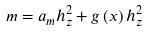Convert formula to latex. <formula><loc_0><loc_0><loc_500><loc_500>m = a _ { m } h _ { z } ^ { 2 } + g \left ( x \right ) h _ { z } ^ { 2 }</formula> 